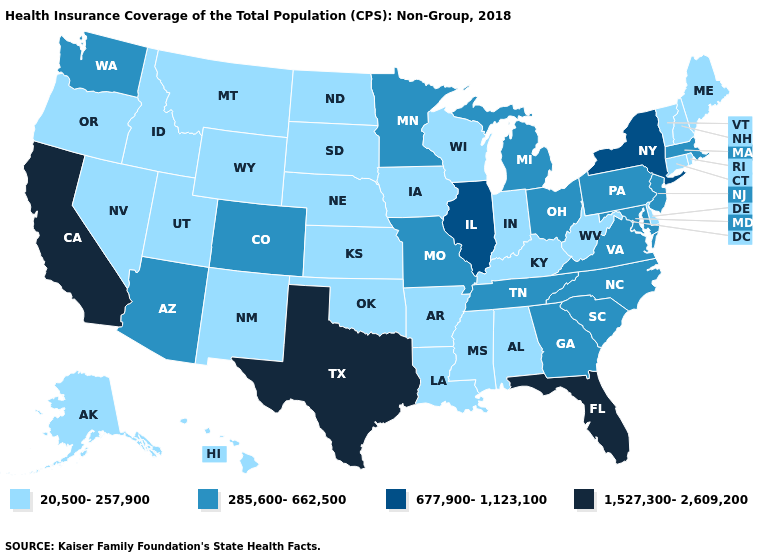How many symbols are there in the legend?
Give a very brief answer. 4. What is the lowest value in the West?
Be succinct. 20,500-257,900. Name the states that have a value in the range 20,500-257,900?
Be succinct. Alabama, Alaska, Arkansas, Connecticut, Delaware, Hawaii, Idaho, Indiana, Iowa, Kansas, Kentucky, Louisiana, Maine, Mississippi, Montana, Nebraska, Nevada, New Hampshire, New Mexico, North Dakota, Oklahoma, Oregon, Rhode Island, South Dakota, Utah, Vermont, West Virginia, Wisconsin, Wyoming. Does the map have missing data?
Be succinct. No. Does the map have missing data?
Quick response, please. No. What is the value of Oregon?
Concise answer only. 20,500-257,900. What is the value of Idaho?
Answer briefly. 20,500-257,900. Name the states that have a value in the range 1,527,300-2,609,200?
Quick response, please. California, Florida, Texas. What is the value of Tennessee?
Be succinct. 285,600-662,500. Does the map have missing data?
Be succinct. No. Does Maine have the highest value in the USA?
Be succinct. No. Name the states that have a value in the range 677,900-1,123,100?
Write a very short answer. Illinois, New York. What is the value of North Dakota?
Quick response, please. 20,500-257,900. Among the states that border Arkansas , which have the lowest value?
Quick response, please. Louisiana, Mississippi, Oklahoma. Which states have the lowest value in the USA?
Quick response, please. Alabama, Alaska, Arkansas, Connecticut, Delaware, Hawaii, Idaho, Indiana, Iowa, Kansas, Kentucky, Louisiana, Maine, Mississippi, Montana, Nebraska, Nevada, New Hampshire, New Mexico, North Dakota, Oklahoma, Oregon, Rhode Island, South Dakota, Utah, Vermont, West Virginia, Wisconsin, Wyoming. 